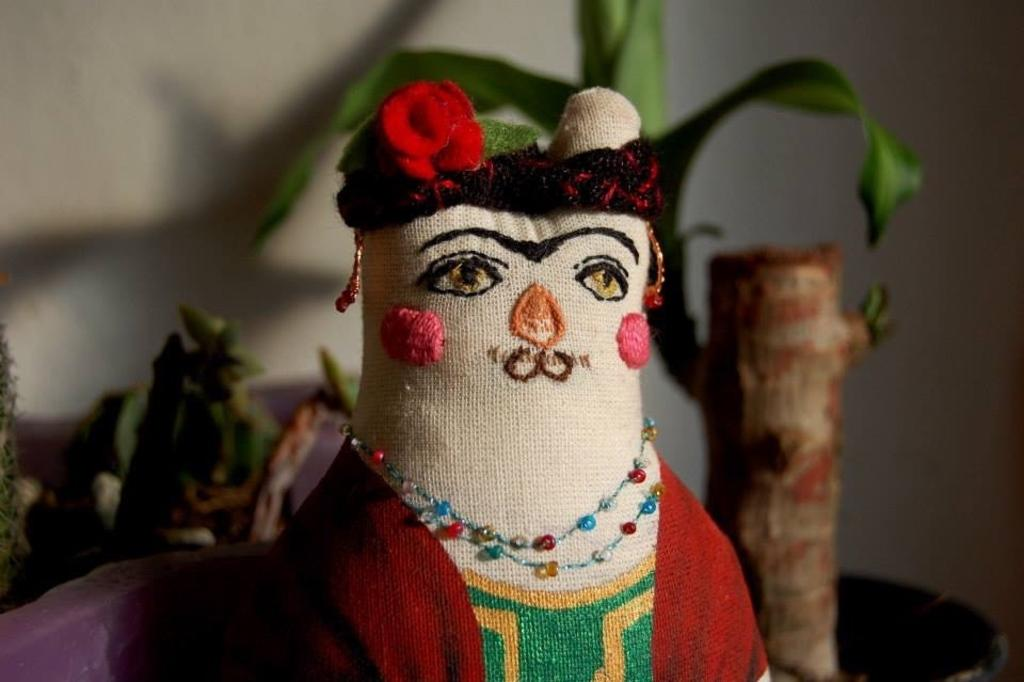What object can be seen in the picture? There is a toy in the picture. What can be seen in the background of the picture? There are planets visible in the background of the picture. What type of structure is in the background of the picture? There is a wall in the background of the picture. Can you see any rabbits hopping in the river in the image? There is no river or rabbits present in the image. 